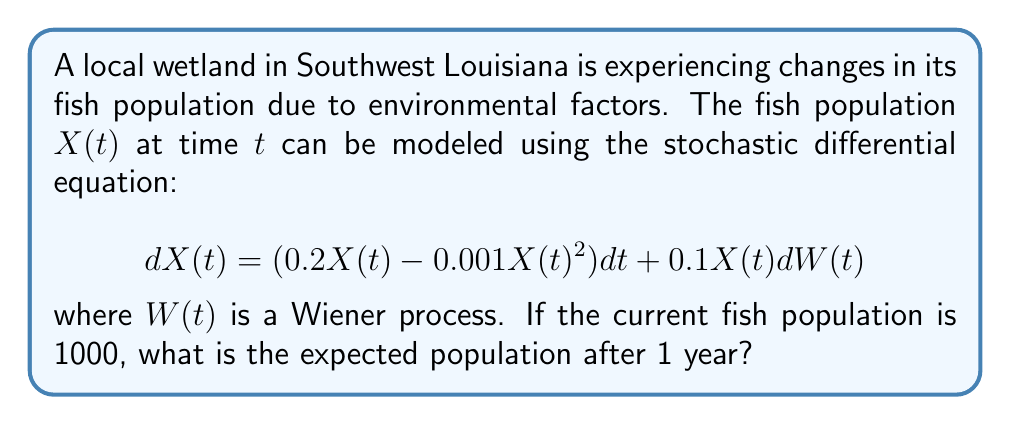Can you answer this question? To solve this problem, we need to follow these steps:

1) The given stochastic differential equation is in the form of a geometric Brownian motion with a logistic growth term:

   $$dX(t) = (aX(t) - bX(t)^2)dt + \sigma X(t)dW(t)$$

   where $a = 0.2$, $b = 0.001$, and $\sigma = 0.1$

2) For this type of SDE, the expected value of $X(t)$ follows the deterministic logistic equation:

   $$\frac{dE[X(t)]}{dt} = aE[X(t)] - bE[X(t)]^2$$

3) The solution to this deterministic equation is:

   $$E[X(t)] = \frac{K}{1 + (\frac{K}{X_0} - 1)e^{-at}}$$

   where $K = \frac{a}{b}$ is the carrying capacity and $X_0$ is the initial population.

4) In our case:
   $K = \frac{0.2}{0.001} = 200$
   $X_0 = 1000$
   $a = 0.2$
   $t = 1$ (1 year)

5) Substituting these values:

   $$E[X(1)] = \frac{200}{1 + (\frac{200}{1000} - 1)e^{-0.2 \cdot 1}}$$

6) Calculating:
   $$E[X(1)] = \frac{200}{1 + (-0.8)e^{-0.2}} \approx 181.8$$

Therefore, the expected fish population after 1 year is approximately 182 fish.
Answer: 182 fish 